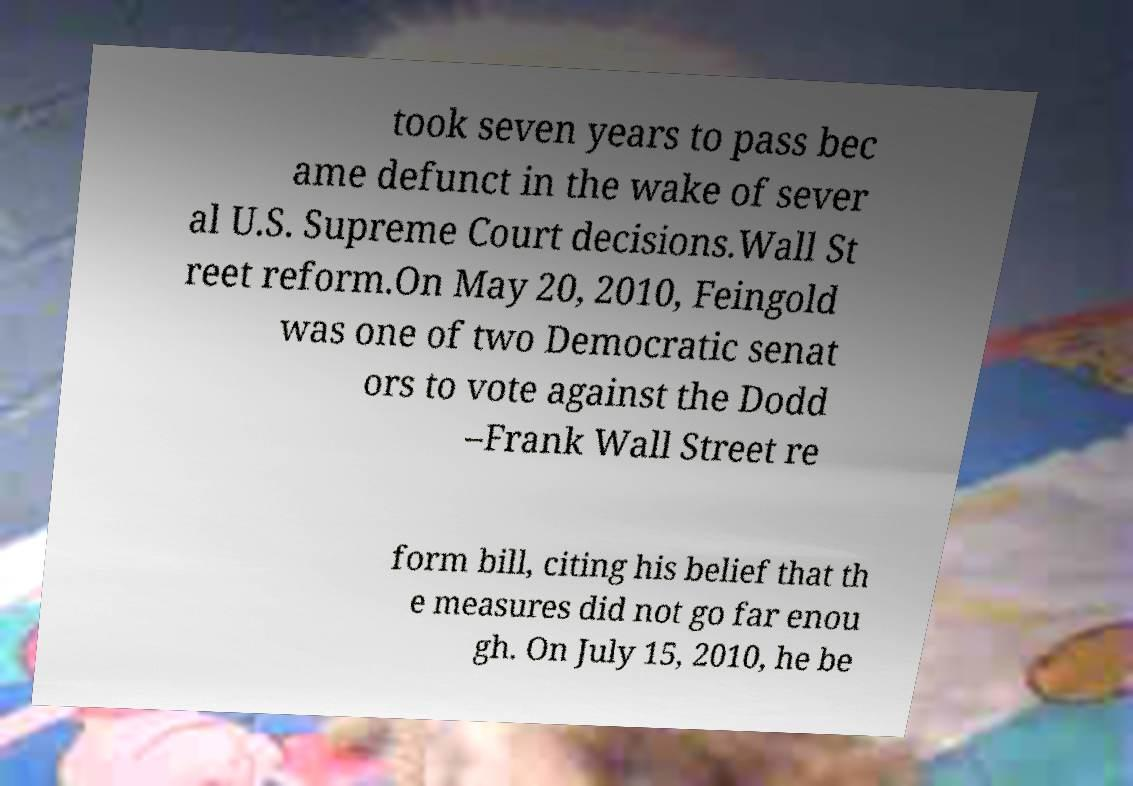Could you extract and type out the text from this image? took seven years to pass bec ame defunct in the wake of sever al U.S. Supreme Court decisions.Wall St reet reform.On May 20, 2010, Feingold was one of two Democratic senat ors to vote against the Dodd –Frank Wall Street re form bill, citing his belief that th e measures did not go far enou gh. On July 15, 2010, he be 